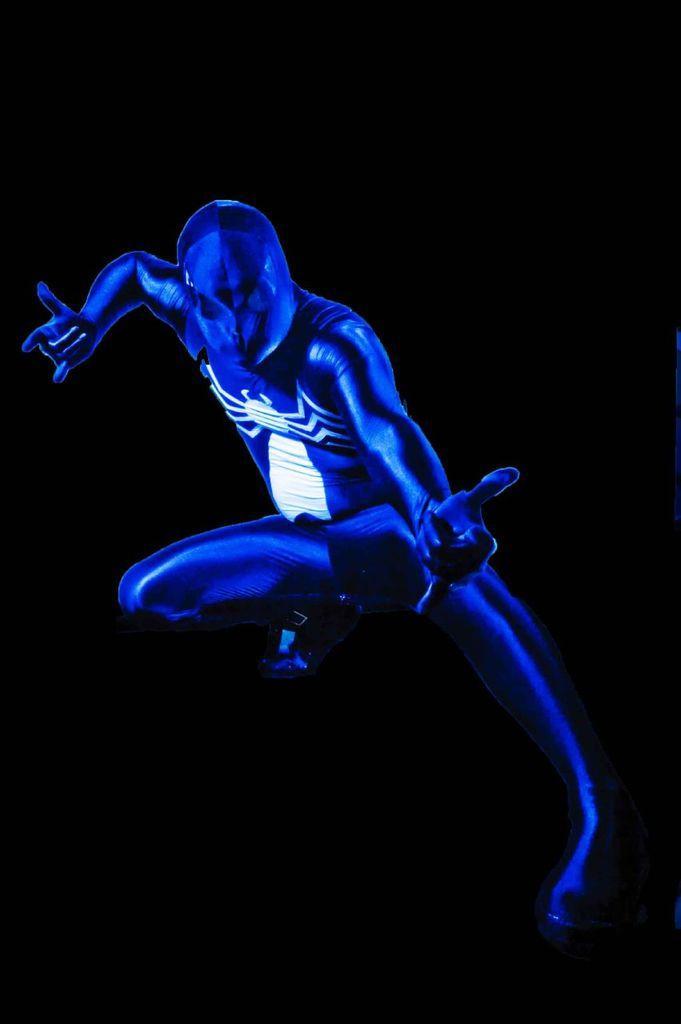Describe this image in one or two sentences. This is an animated image of a person who is wearing a blue color suit with a spider image and the background is dark. 